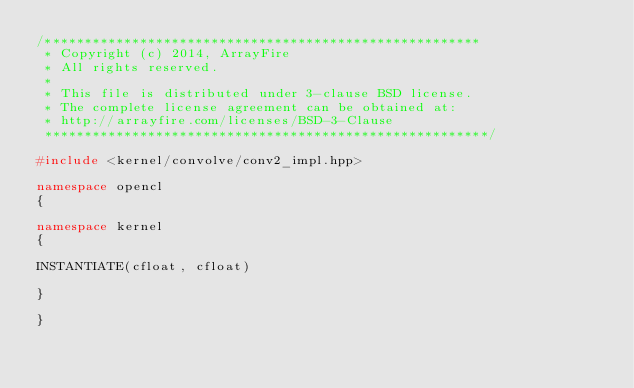Convert code to text. <code><loc_0><loc_0><loc_500><loc_500><_C++_>/*******************************************************
 * Copyright (c) 2014, ArrayFire
 * All rights reserved.
 *
 * This file is distributed under 3-clause BSD license.
 * The complete license agreement can be obtained at:
 * http://arrayfire.com/licenses/BSD-3-Clause
 ********************************************************/

#include <kernel/convolve/conv2_impl.hpp>

namespace opencl
{

namespace kernel
{

INSTANTIATE(cfloat, cfloat)

}

}
</code> 